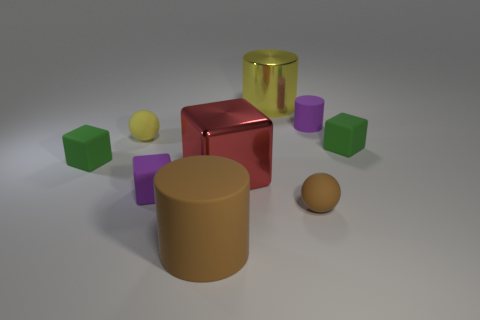Add 1 green rubber cubes. How many objects exist? 10 Subtract all cylinders. How many objects are left? 6 Add 6 purple cylinders. How many purple cylinders are left? 7 Add 5 tiny green metal cylinders. How many tiny green metal cylinders exist? 5 Subtract 0 blue cubes. How many objects are left? 9 Subtract all purple rubber cylinders. Subtract all small matte cylinders. How many objects are left? 7 